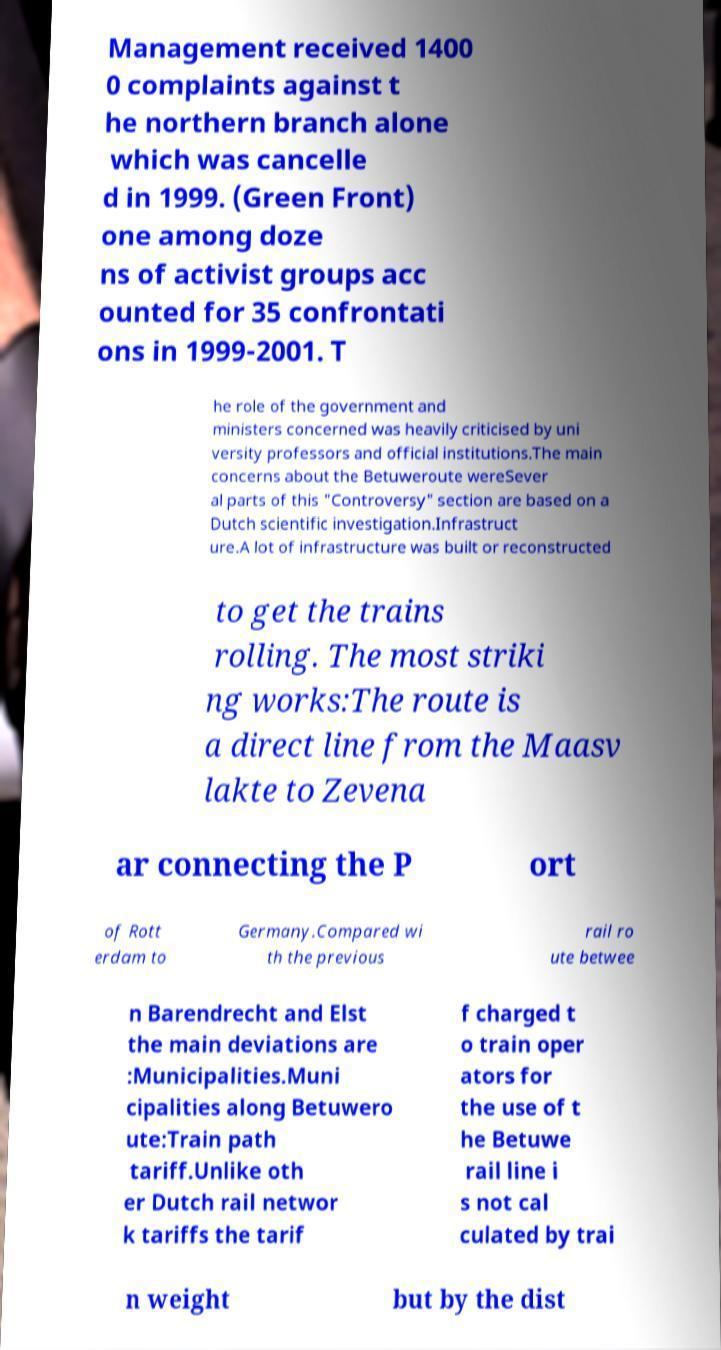What messages or text are displayed in this image? I need them in a readable, typed format. Management received 1400 0 complaints against t he northern branch alone which was cancelle d in 1999. (Green Front) one among doze ns of activist groups acc ounted for 35 confrontati ons in 1999-2001. T he role of the government and ministers concerned was heavily criticised by uni versity professors and official institutions.The main concerns about the Betuweroute wereSever al parts of this "Controversy" section are based on a Dutch scientific investigation.Infrastruct ure.A lot of infrastructure was built or reconstructed to get the trains rolling. The most striki ng works:The route is a direct line from the Maasv lakte to Zevena ar connecting the P ort of Rott erdam to Germany.Compared wi th the previous rail ro ute betwee n Barendrecht and Elst the main deviations are :Municipalities.Muni cipalities along Betuwero ute:Train path tariff.Unlike oth er Dutch rail networ k tariffs the tarif f charged t o train oper ators for the use of t he Betuwe rail line i s not cal culated by trai n weight but by the dist 